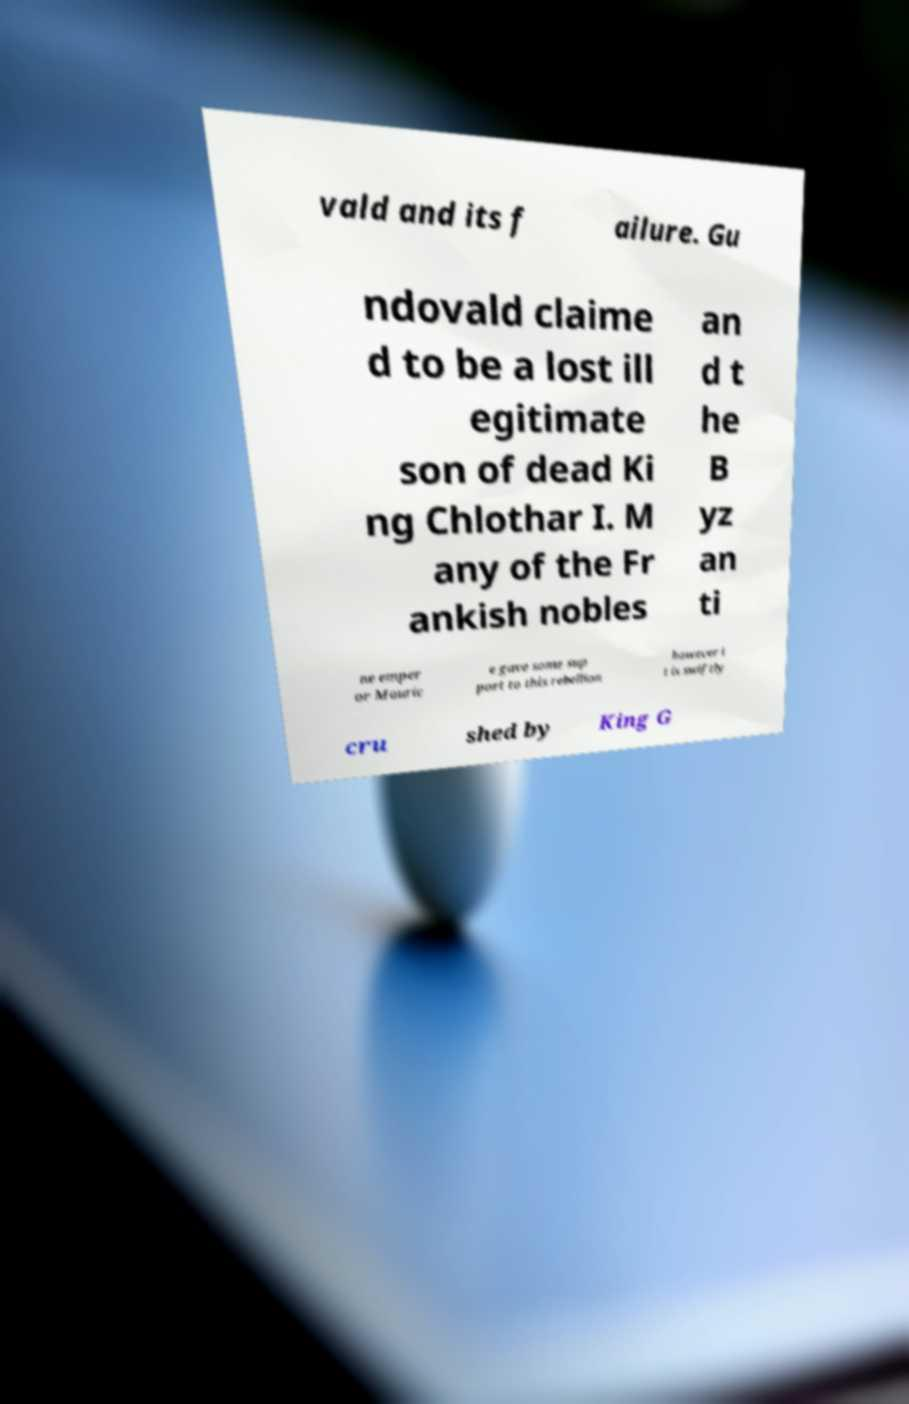Please identify and transcribe the text found in this image. vald and its f ailure. Gu ndovald claime d to be a lost ill egitimate son of dead Ki ng Chlothar I. M any of the Fr ankish nobles an d t he B yz an ti ne emper or Mauric e gave some sup port to this rebellion however i t is swiftly cru shed by King G 